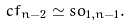<formula> <loc_0><loc_0><loc_500><loc_500>c f _ { n - 2 } \simeq s o _ { 1 , n - 1 } .</formula> 